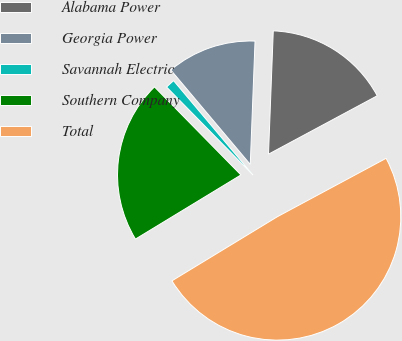Convert chart. <chart><loc_0><loc_0><loc_500><loc_500><pie_chart><fcel>Alabama Power<fcel>Georgia Power<fcel>Savannah Electric<fcel>Southern Company<fcel>Total<nl><fcel>16.54%<fcel>11.75%<fcel>1.22%<fcel>21.34%<fcel>49.15%<nl></chart> 